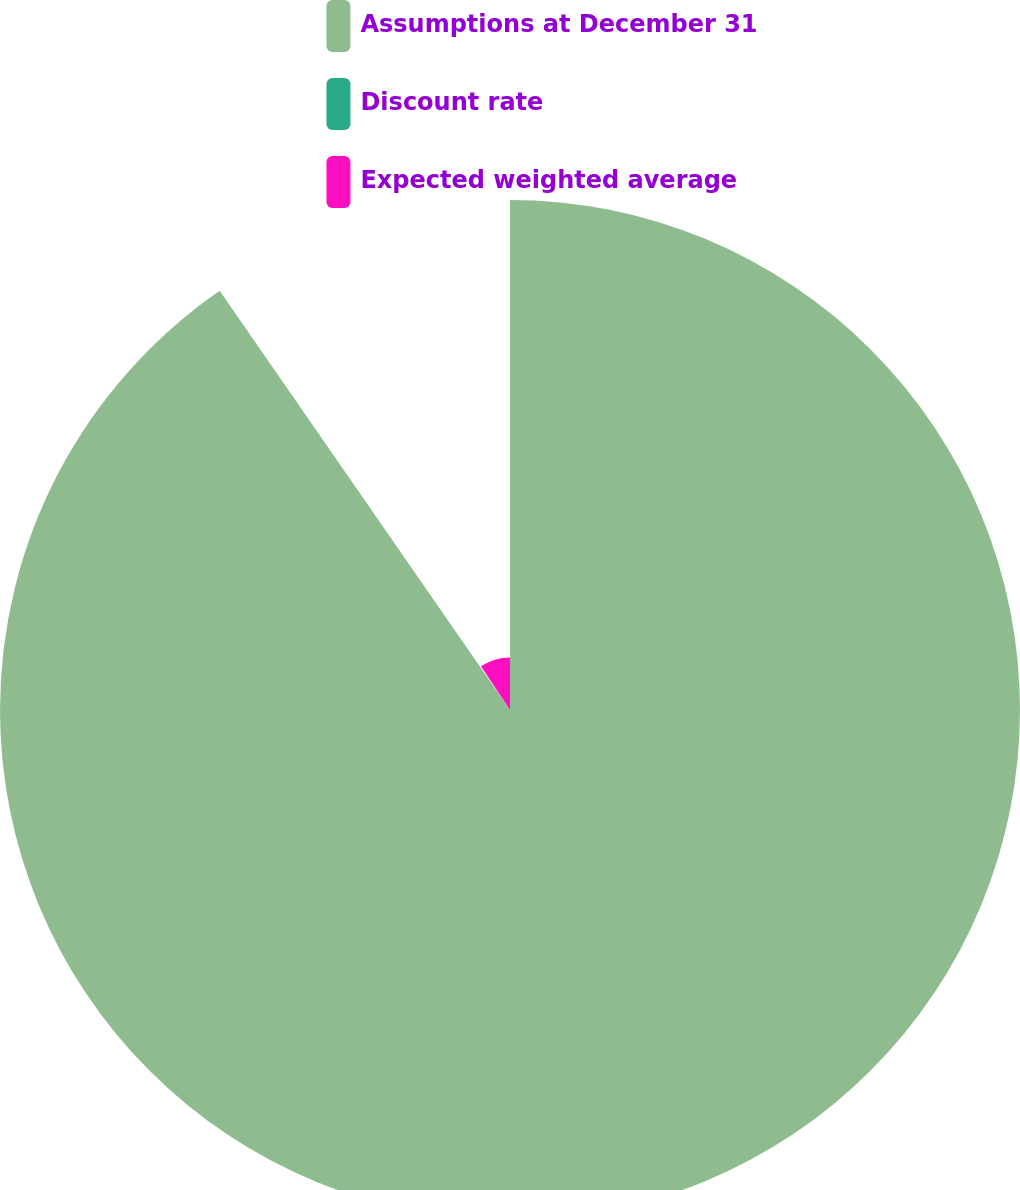Convert chart to OTSL. <chart><loc_0><loc_0><loc_500><loc_500><pie_chart><fcel>Assumptions at December 31<fcel>Discount rate<fcel>Expected weighted average<nl><fcel>90.36%<fcel>0.32%<fcel>9.32%<nl></chart> 